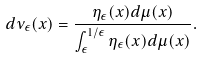Convert formula to latex. <formula><loc_0><loc_0><loc_500><loc_500>d \nu _ { \epsilon } ( x ) = \frac { \eta _ { \epsilon } ( x ) d \mu ( x ) } { \int _ { \epsilon } ^ { 1 / \epsilon } { \eta _ { \epsilon } ( x ) d \mu ( x ) } } .</formula> 